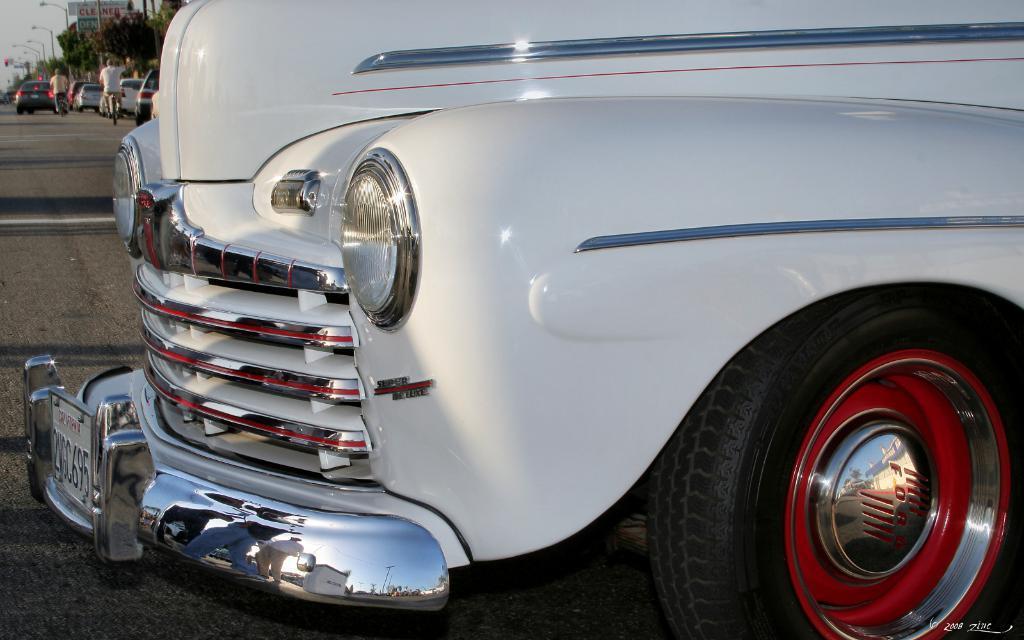Please provide a concise description of this image. In this picture there is a vehicle in the foreground and there is text on the vehicle and there are reflections of group of people on the vehicle. At the back there are vehicles and there are two persons riding motorbike on the road and there are trees and street lights. At the top there is sky. At the bottom there is a road. 